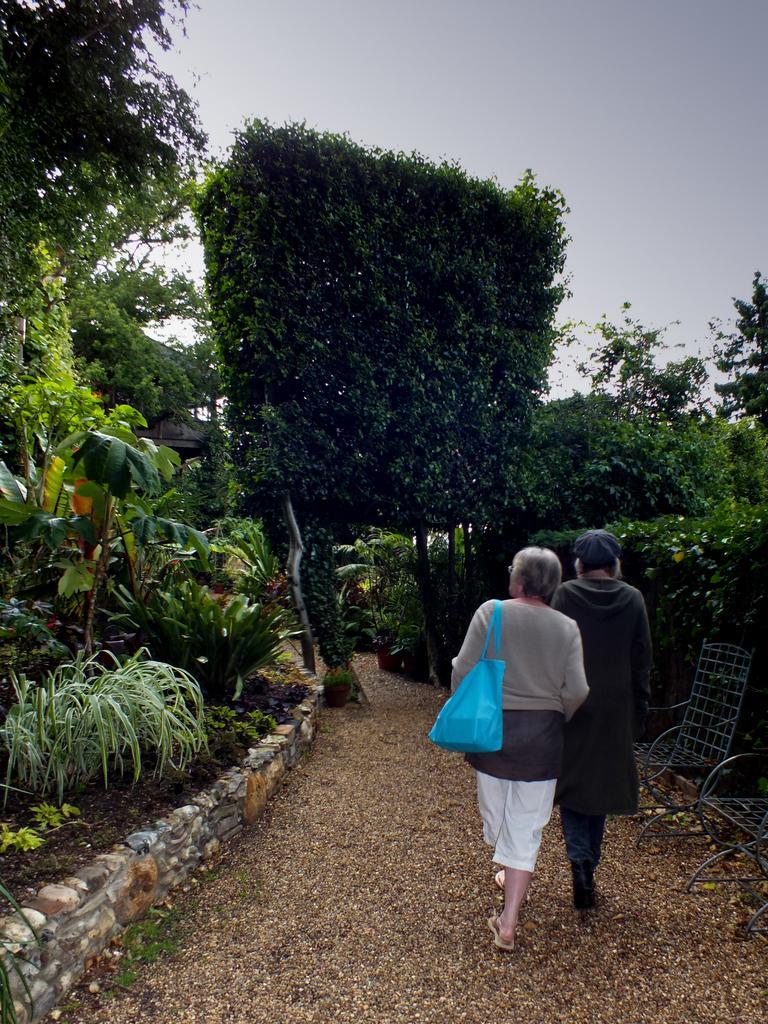How would you summarize this image in a sentence or two? In this image we can see two persons walking on the ground, there are two chairs beside the person, a person is wearing a handbag and there are few trees and the sky in the background. 